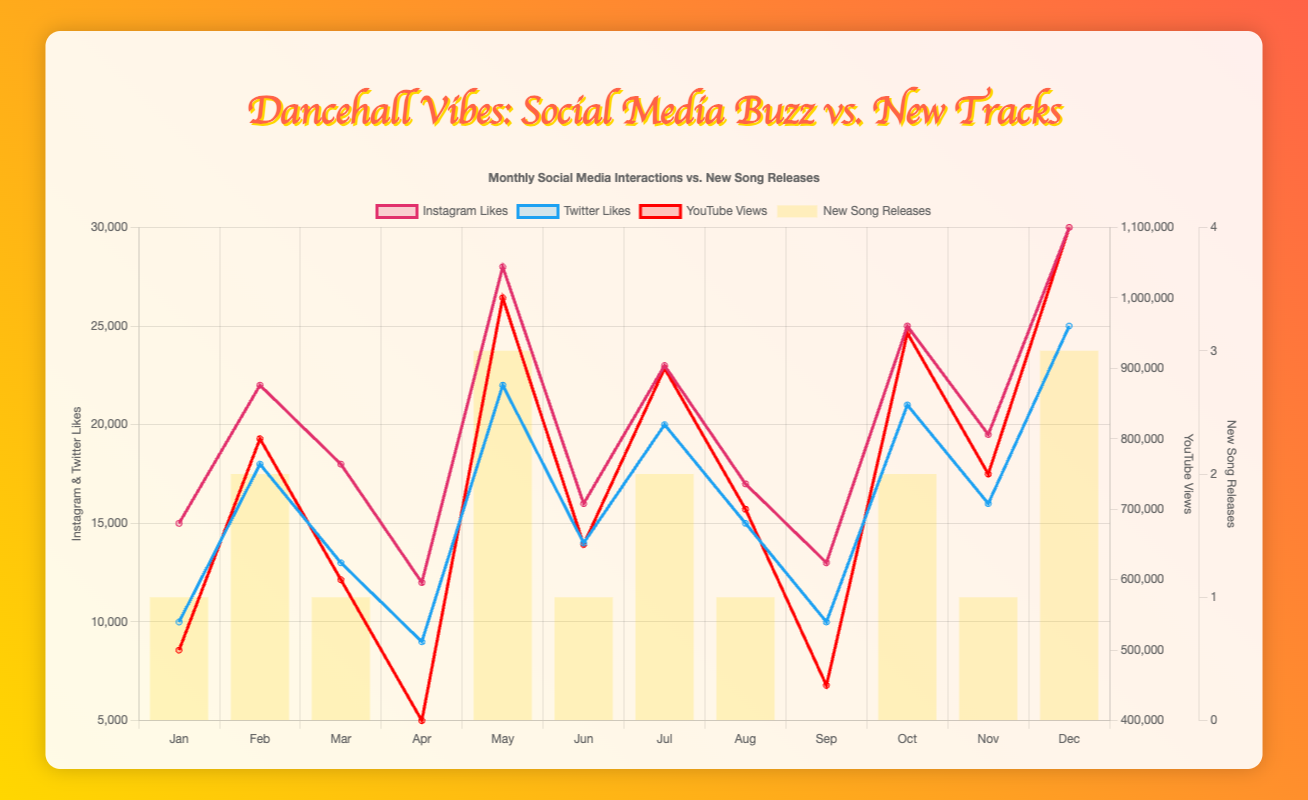Which month had the highest number of YouTube views? Look at the "YouTube Views" line and find the highest point, which corresponds to December.
Answer: December In which month was there no new song release, yet the highest Instagram likes were recorded? Look for months with zero new song releases and then compare their Instagram likes. There are only two such months (April and September), of which September has the highest Instagram likes with 13000.
Answer: September What is the average number of new song releases per month in 2023? Sum the number of new song releases across all months and divide by 12. The total releases are 18 (1+2+1+0+3+1+2+1+0+2+1+3), therefore the average is 18/12.
Answer: 1.5 Compare the Instagram likes and Twitter likes in July. Which platform received more interactions? Look at the data points for July and compare. Instagram likes are 23000, and Twitter likes are 20000, so Instagram received more interactions in July.
Answer: Instagram During which month(s) did new song releases not significantly impact social media interactions? Identify months with new song releases but minimal differences in interactions. April (0), September (0), and the interactions were lower compared to other months. Therefore, these releases had a lesser impact in those months.
Answer: April, September What is the total number of Instagram likes for the months with new song releases in 2023? Add Instagram likes for months with new releases: January, February, March, May, June, July, August, October, November, December. The sum is 15000+22000+18000+28000+16000+23000+17000+25000+19500+30000 = 243500.
Answer: 243500 Is there a trend between the number of new song releases and Twitter likes? Generally, notice the spikes in Twitter likes when new song releases are higher, such as February, May, July, October, December.
Answer: Yes, there is a trend Which month saw the largest increase in Twitter likes compared to the previous month? Compare the increase month by month. The largest change is from April (9000) to May (22000), an increase of 13000.
Answer: May What month had the lowest YouTube views, and how many new song releases were there in that month? The lowest number of views is in April (400000), with zero new song releases.
Answer: April with 0 releases 